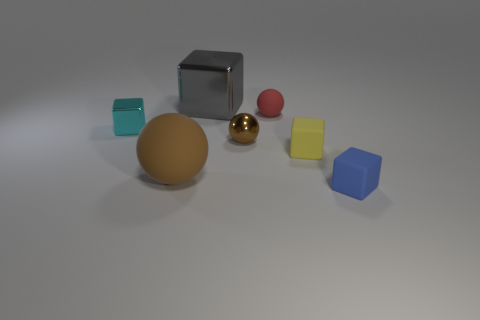Add 3 tiny brown things. How many objects exist? 10 Subtract all blocks. How many objects are left? 3 Add 7 brown metallic balls. How many brown metallic balls are left? 8 Add 3 tiny yellow blocks. How many tiny yellow blocks exist? 4 Subtract 0 yellow spheres. How many objects are left? 7 Subtract all blue cylinders. Subtract all tiny blue blocks. How many objects are left? 6 